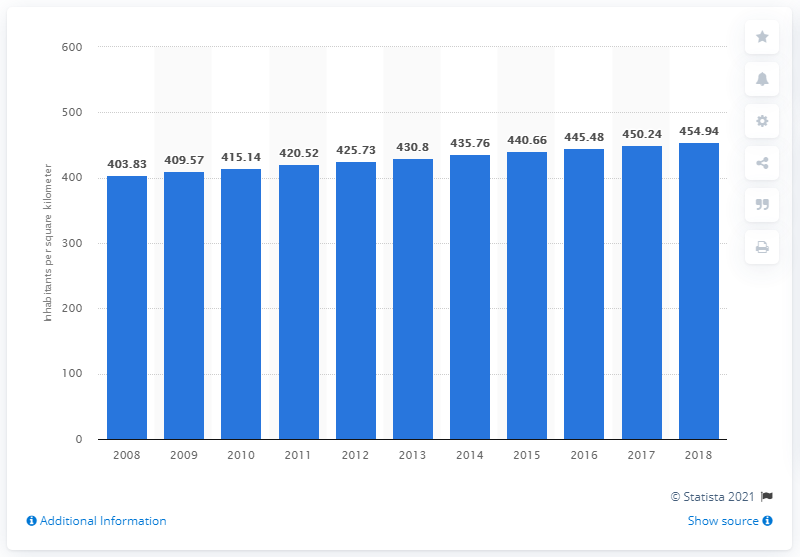Highlight a few significant elements in this photo. In 2018, the population density in India was approximately 454.94 people per square kilometer. 